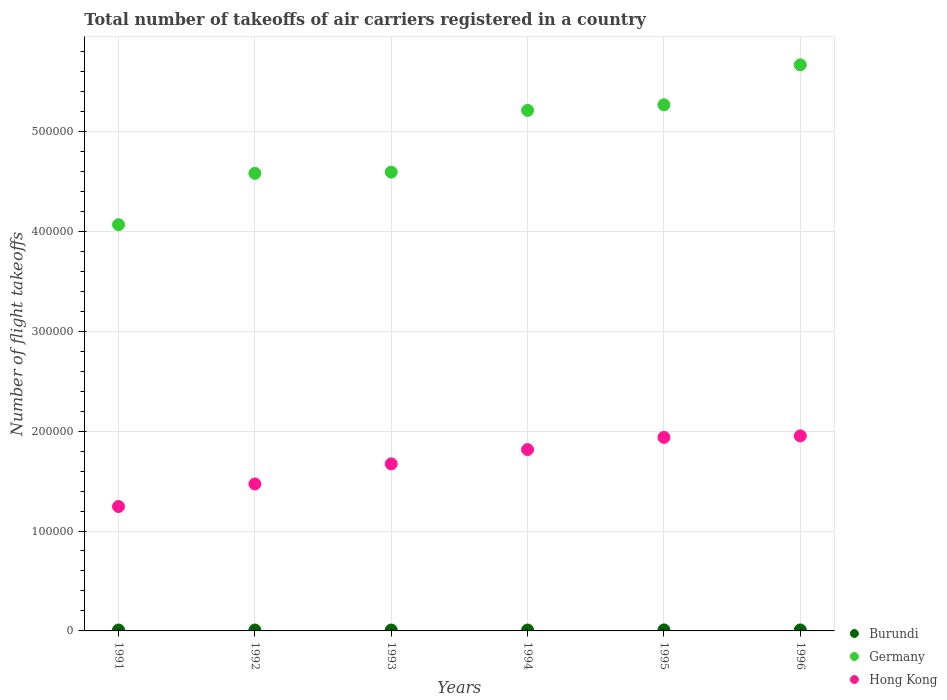How many different coloured dotlines are there?
Your answer should be very brief. 3. Across all years, what is the maximum total number of flight takeoffs in Hong Kong?
Provide a short and direct response. 1.95e+05. Across all years, what is the minimum total number of flight takeoffs in Germany?
Keep it short and to the point. 4.07e+05. In which year was the total number of flight takeoffs in Burundi minimum?
Provide a short and direct response. 1991. What is the total total number of flight takeoffs in Burundi in the graph?
Offer a very short reply. 5600. What is the difference between the total number of flight takeoffs in Burundi in 1993 and that in 1995?
Provide a succinct answer. -100. What is the difference between the total number of flight takeoffs in Burundi in 1993 and the total number of flight takeoffs in Germany in 1994?
Give a very brief answer. -5.20e+05. What is the average total number of flight takeoffs in Hong Kong per year?
Keep it short and to the point. 1.68e+05. In the year 1994, what is the difference between the total number of flight takeoffs in Germany and total number of flight takeoffs in Burundi?
Give a very brief answer. 5.20e+05. What is the ratio of the total number of flight takeoffs in Germany in 1991 to that in 1992?
Provide a short and direct response. 0.89. Is the difference between the total number of flight takeoffs in Germany in 1992 and 1993 greater than the difference between the total number of flight takeoffs in Burundi in 1992 and 1993?
Make the answer very short. No. What is the difference between the highest and the second highest total number of flight takeoffs in Hong Kong?
Offer a terse response. 1500. Is it the case that in every year, the sum of the total number of flight takeoffs in Burundi and total number of flight takeoffs in Germany  is greater than the total number of flight takeoffs in Hong Kong?
Ensure brevity in your answer.  Yes. Does the graph contain any zero values?
Provide a short and direct response. No. Does the graph contain grids?
Offer a terse response. Yes. How many legend labels are there?
Offer a very short reply. 3. How are the legend labels stacked?
Offer a terse response. Vertical. What is the title of the graph?
Your answer should be very brief. Total number of takeoffs of air carriers registered in a country. What is the label or title of the Y-axis?
Provide a short and direct response. Number of flight takeoffs. What is the Number of flight takeoffs of Burundi in 1991?
Provide a succinct answer. 900. What is the Number of flight takeoffs of Germany in 1991?
Give a very brief answer. 4.07e+05. What is the Number of flight takeoffs of Hong Kong in 1991?
Your answer should be compact. 1.24e+05. What is the Number of flight takeoffs of Burundi in 1992?
Provide a succinct answer. 900. What is the Number of flight takeoffs in Germany in 1992?
Ensure brevity in your answer.  4.58e+05. What is the Number of flight takeoffs in Hong Kong in 1992?
Offer a terse response. 1.47e+05. What is the Number of flight takeoffs in Burundi in 1993?
Ensure brevity in your answer.  900. What is the Number of flight takeoffs in Germany in 1993?
Provide a short and direct response. 4.59e+05. What is the Number of flight takeoffs in Hong Kong in 1993?
Provide a succinct answer. 1.67e+05. What is the Number of flight takeoffs in Burundi in 1994?
Offer a very short reply. 900. What is the Number of flight takeoffs in Germany in 1994?
Your response must be concise. 5.21e+05. What is the Number of flight takeoffs in Hong Kong in 1994?
Make the answer very short. 1.82e+05. What is the Number of flight takeoffs of Burundi in 1995?
Your answer should be very brief. 1000. What is the Number of flight takeoffs of Germany in 1995?
Keep it short and to the point. 5.27e+05. What is the Number of flight takeoffs in Hong Kong in 1995?
Provide a short and direct response. 1.94e+05. What is the Number of flight takeoffs of Germany in 1996?
Give a very brief answer. 5.67e+05. What is the Number of flight takeoffs of Hong Kong in 1996?
Keep it short and to the point. 1.95e+05. Across all years, what is the maximum Number of flight takeoffs of Germany?
Provide a short and direct response. 5.67e+05. Across all years, what is the maximum Number of flight takeoffs of Hong Kong?
Give a very brief answer. 1.95e+05. Across all years, what is the minimum Number of flight takeoffs of Burundi?
Your answer should be very brief. 900. Across all years, what is the minimum Number of flight takeoffs in Germany?
Keep it short and to the point. 4.07e+05. Across all years, what is the minimum Number of flight takeoffs in Hong Kong?
Keep it short and to the point. 1.24e+05. What is the total Number of flight takeoffs in Burundi in the graph?
Make the answer very short. 5600. What is the total Number of flight takeoffs in Germany in the graph?
Your response must be concise. 2.94e+06. What is the total Number of flight takeoffs of Hong Kong in the graph?
Provide a short and direct response. 1.01e+06. What is the difference between the Number of flight takeoffs in Germany in 1991 and that in 1992?
Provide a succinct answer. -5.14e+04. What is the difference between the Number of flight takeoffs in Hong Kong in 1991 and that in 1992?
Provide a succinct answer. -2.26e+04. What is the difference between the Number of flight takeoffs in Germany in 1991 and that in 1993?
Offer a terse response. -5.26e+04. What is the difference between the Number of flight takeoffs of Hong Kong in 1991 and that in 1993?
Your response must be concise. -4.27e+04. What is the difference between the Number of flight takeoffs of Germany in 1991 and that in 1994?
Keep it short and to the point. -1.14e+05. What is the difference between the Number of flight takeoffs of Hong Kong in 1991 and that in 1994?
Offer a terse response. -5.70e+04. What is the difference between the Number of flight takeoffs of Burundi in 1991 and that in 1995?
Make the answer very short. -100. What is the difference between the Number of flight takeoffs of Germany in 1991 and that in 1995?
Ensure brevity in your answer.  -1.20e+05. What is the difference between the Number of flight takeoffs of Hong Kong in 1991 and that in 1995?
Make the answer very short. -6.92e+04. What is the difference between the Number of flight takeoffs in Burundi in 1991 and that in 1996?
Your answer should be compact. -100. What is the difference between the Number of flight takeoffs in Hong Kong in 1991 and that in 1996?
Offer a very short reply. -7.07e+04. What is the difference between the Number of flight takeoffs in Germany in 1992 and that in 1993?
Keep it short and to the point. -1200. What is the difference between the Number of flight takeoffs of Hong Kong in 1992 and that in 1993?
Your answer should be very brief. -2.01e+04. What is the difference between the Number of flight takeoffs in Germany in 1992 and that in 1994?
Offer a terse response. -6.30e+04. What is the difference between the Number of flight takeoffs in Hong Kong in 1992 and that in 1994?
Make the answer very short. -3.44e+04. What is the difference between the Number of flight takeoffs of Burundi in 1992 and that in 1995?
Give a very brief answer. -100. What is the difference between the Number of flight takeoffs of Germany in 1992 and that in 1995?
Ensure brevity in your answer.  -6.86e+04. What is the difference between the Number of flight takeoffs in Hong Kong in 1992 and that in 1995?
Make the answer very short. -4.66e+04. What is the difference between the Number of flight takeoffs of Burundi in 1992 and that in 1996?
Make the answer very short. -100. What is the difference between the Number of flight takeoffs of Germany in 1992 and that in 1996?
Provide a succinct answer. -1.09e+05. What is the difference between the Number of flight takeoffs of Hong Kong in 1992 and that in 1996?
Your response must be concise. -4.81e+04. What is the difference between the Number of flight takeoffs of Burundi in 1993 and that in 1994?
Provide a short and direct response. 0. What is the difference between the Number of flight takeoffs in Germany in 1993 and that in 1994?
Provide a succinct answer. -6.18e+04. What is the difference between the Number of flight takeoffs of Hong Kong in 1993 and that in 1994?
Make the answer very short. -1.43e+04. What is the difference between the Number of flight takeoffs in Burundi in 1993 and that in 1995?
Provide a succinct answer. -100. What is the difference between the Number of flight takeoffs in Germany in 1993 and that in 1995?
Your response must be concise. -6.74e+04. What is the difference between the Number of flight takeoffs of Hong Kong in 1993 and that in 1995?
Your answer should be compact. -2.65e+04. What is the difference between the Number of flight takeoffs in Burundi in 1993 and that in 1996?
Make the answer very short. -100. What is the difference between the Number of flight takeoffs of Germany in 1993 and that in 1996?
Your response must be concise. -1.07e+05. What is the difference between the Number of flight takeoffs of Hong Kong in 1993 and that in 1996?
Offer a terse response. -2.80e+04. What is the difference between the Number of flight takeoffs of Burundi in 1994 and that in 1995?
Your answer should be very brief. -100. What is the difference between the Number of flight takeoffs in Germany in 1994 and that in 1995?
Ensure brevity in your answer.  -5600. What is the difference between the Number of flight takeoffs of Hong Kong in 1994 and that in 1995?
Give a very brief answer. -1.22e+04. What is the difference between the Number of flight takeoffs of Burundi in 1994 and that in 1996?
Make the answer very short. -100. What is the difference between the Number of flight takeoffs in Germany in 1994 and that in 1996?
Your answer should be compact. -4.56e+04. What is the difference between the Number of flight takeoffs in Hong Kong in 1994 and that in 1996?
Provide a short and direct response. -1.37e+04. What is the difference between the Number of flight takeoffs of Burundi in 1995 and that in 1996?
Give a very brief answer. 0. What is the difference between the Number of flight takeoffs in Germany in 1995 and that in 1996?
Ensure brevity in your answer.  -4.00e+04. What is the difference between the Number of flight takeoffs in Hong Kong in 1995 and that in 1996?
Offer a terse response. -1500. What is the difference between the Number of flight takeoffs of Burundi in 1991 and the Number of flight takeoffs of Germany in 1992?
Your answer should be compact. -4.57e+05. What is the difference between the Number of flight takeoffs of Burundi in 1991 and the Number of flight takeoffs of Hong Kong in 1992?
Offer a very short reply. -1.46e+05. What is the difference between the Number of flight takeoffs of Germany in 1991 and the Number of flight takeoffs of Hong Kong in 1992?
Ensure brevity in your answer.  2.60e+05. What is the difference between the Number of flight takeoffs in Burundi in 1991 and the Number of flight takeoffs in Germany in 1993?
Offer a terse response. -4.58e+05. What is the difference between the Number of flight takeoffs in Burundi in 1991 and the Number of flight takeoffs in Hong Kong in 1993?
Your response must be concise. -1.66e+05. What is the difference between the Number of flight takeoffs of Germany in 1991 and the Number of flight takeoffs of Hong Kong in 1993?
Ensure brevity in your answer.  2.39e+05. What is the difference between the Number of flight takeoffs of Burundi in 1991 and the Number of flight takeoffs of Germany in 1994?
Give a very brief answer. -5.20e+05. What is the difference between the Number of flight takeoffs of Burundi in 1991 and the Number of flight takeoffs of Hong Kong in 1994?
Offer a very short reply. -1.81e+05. What is the difference between the Number of flight takeoffs of Germany in 1991 and the Number of flight takeoffs of Hong Kong in 1994?
Offer a very short reply. 2.25e+05. What is the difference between the Number of flight takeoffs in Burundi in 1991 and the Number of flight takeoffs in Germany in 1995?
Offer a terse response. -5.26e+05. What is the difference between the Number of flight takeoffs of Burundi in 1991 and the Number of flight takeoffs of Hong Kong in 1995?
Ensure brevity in your answer.  -1.93e+05. What is the difference between the Number of flight takeoffs of Germany in 1991 and the Number of flight takeoffs of Hong Kong in 1995?
Give a very brief answer. 2.13e+05. What is the difference between the Number of flight takeoffs in Burundi in 1991 and the Number of flight takeoffs in Germany in 1996?
Your answer should be compact. -5.66e+05. What is the difference between the Number of flight takeoffs of Burundi in 1991 and the Number of flight takeoffs of Hong Kong in 1996?
Make the answer very short. -1.94e+05. What is the difference between the Number of flight takeoffs in Germany in 1991 and the Number of flight takeoffs in Hong Kong in 1996?
Your answer should be very brief. 2.11e+05. What is the difference between the Number of flight takeoffs in Burundi in 1992 and the Number of flight takeoffs in Germany in 1993?
Ensure brevity in your answer.  -4.58e+05. What is the difference between the Number of flight takeoffs in Burundi in 1992 and the Number of flight takeoffs in Hong Kong in 1993?
Give a very brief answer. -1.66e+05. What is the difference between the Number of flight takeoffs of Germany in 1992 and the Number of flight takeoffs of Hong Kong in 1993?
Make the answer very short. 2.91e+05. What is the difference between the Number of flight takeoffs in Burundi in 1992 and the Number of flight takeoffs in Germany in 1994?
Make the answer very short. -5.20e+05. What is the difference between the Number of flight takeoffs of Burundi in 1992 and the Number of flight takeoffs of Hong Kong in 1994?
Make the answer very short. -1.81e+05. What is the difference between the Number of flight takeoffs in Germany in 1992 and the Number of flight takeoffs in Hong Kong in 1994?
Provide a succinct answer. 2.76e+05. What is the difference between the Number of flight takeoffs of Burundi in 1992 and the Number of flight takeoffs of Germany in 1995?
Your answer should be very brief. -5.26e+05. What is the difference between the Number of flight takeoffs in Burundi in 1992 and the Number of flight takeoffs in Hong Kong in 1995?
Your answer should be compact. -1.93e+05. What is the difference between the Number of flight takeoffs of Germany in 1992 and the Number of flight takeoffs of Hong Kong in 1995?
Offer a terse response. 2.64e+05. What is the difference between the Number of flight takeoffs in Burundi in 1992 and the Number of flight takeoffs in Germany in 1996?
Offer a terse response. -5.66e+05. What is the difference between the Number of flight takeoffs of Burundi in 1992 and the Number of flight takeoffs of Hong Kong in 1996?
Ensure brevity in your answer.  -1.94e+05. What is the difference between the Number of flight takeoffs of Germany in 1992 and the Number of flight takeoffs of Hong Kong in 1996?
Ensure brevity in your answer.  2.63e+05. What is the difference between the Number of flight takeoffs of Burundi in 1993 and the Number of flight takeoffs of Germany in 1994?
Provide a short and direct response. -5.20e+05. What is the difference between the Number of flight takeoffs in Burundi in 1993 and the Number of flight takeoffs in Hong Kong in 1994?
Your answer should be very brief. -1.81e+05. What is the difference between the Number of flight takeoffs of Germany in 1993 and the Number of flight takeoffs of Hong Kong in 1994?
Offer a terse response. 2.78e+05. What is the difference between the Number of flight takeoffs in Burundi in 1993 and the Number of flight takeoffs in Germany in 1995?
Provide a short and direct response. -5.26e+05. What is the difference between the Number of flight takeoffs of Burundi in 1993 and the Number of flight takeoffs of Hong Kong in 1995?
Offer a very short reply. -1.93e+05. What is the difference between the Number of flight takeoffs in Germany in 1993 and the Number of flight takeoffs in Hong Kong in 1995?
Your response must be concise. 2.66e+05. What is the difference between the Number of flight takeoffs of Burundi in 1993 and the Number of flight takeoffs of Germany in 1996?
Keep it short and to the point. -5.66e+05. What is the difference between the Number of flight takeoffs of Burundi in 1993 and the Number of flight takeoffs of Hong Kong in 1996?
Offer a very short reply. -1.94e+05. What is the difference between the Number of flight takeoffs in Germany in 1993 and the Number of flight takeoffs in Hong Kong in 1996?
Provide a short and direct response. 2.64e+05. What is the difference between the Number of flight takeoffs of Burundi in 1994 and the Number of flight takeoffs of Germany in 1995?
Ensure brevity in your answer.  -5.26e+05. What is the difference between the Number of flight takeoffs of Burundi in 1994 and the Number of flight takeoffs of Hong Kong in 1995?
Give a very brief answer. -1.93e+05. What is the difference between the Number of flight takeoffs in Germany in 1994 and the Number of flight takeoffs in Hong Kong in 1995?
Keep it short and to the point. 3.27e+05. What is the difference between the Number of flight takeoffs of Burundi in 1994 and the Number of flight takeoffs of Germany in 1996?
Make the answer very short. -5.66e+05. What is the difference between the Number of flight takeoffs of Burundi in 1994 and the Number of flight takeoffs of Hong Kong in 1996?
Give a very brief answer. -1.94e+05. What is the difference between the Number of flight takeoffs in Germany in 1994 and the Number of flight takeoffs in Hong Kong in 1996?
Keep it short and to the point. 3.26e+05. What is the difference between the Number of flight takeoffs of Burundi in 1995 and the Number of flight takeoffs of Germany in 1996?
Your response must be concise. -5.66e+05. What is the difference between the Number of flight takeoffs of Burundi in 1995 and the Number of flight takeoffs of Hong Kong in 1996?
Provide a succinct answer. -1.94e+05. What is the difference between the Number of flight takeoffs of Germany in 1995 and the Number of flight takeoffs of Hong Kong in 1996?
Offer a terse response. 3.31e+05. What is the average Number of flight takeoffs in Burundi per year?
Provide a short and direct response. 933.33. What is the average Number of flight takeoffs in Germany per year?
Give a very brief answer. 4.90e+05. What is the average Number of flight takeoffs of Hong Kong per year?
Give a very brief answer. 1.68e+05. In the year 1991, what is the difference between the Number of flight takeoffs of Burundi and Number of flight takeoffs of Germany?
Provide a short and direct response. -4.06e+05. In the year 1991, what is the difference between the Number of flight takeoffs in Burundi and Number of flight takeoffs in Hong Kong?
Your response must be concise. -1.24e+05. In the year 1991, what is the difference between the Number of flight takeoffs in Germany and Number of flight takeoffs in Hong Kong?
Give a very brief answer. 2.82e+05. In the year 1992, what is the difference between the Number of flight takeoffs in Burundi and Number of flight takeoffs in Germany?
Offer a terse response. -4.57e+05. In the year 1992, what is the difference between the Number of flight takeoffs of Burundi and Number of flight takeoffs of Hong Kong?
Your answer should be compact. -1.46e+05. In the year 1992, what is the difference between the Number of flight takeoffs of Germany and Number of flight takeoffs of Hong Kong?
Your answer should be compact. 3.11e+05. In the year 1993, what is the difference between the Number of flight takeoffs in Burundi and Number of flight takeoffs in Germany?
Your response must be concise. -4.58e+05. In the year 1993, what is the difference between the Number of flight takeoffs of Burundi and Number of flight takeoffs of Hong Kong?
Ensure brevity in your answer.  -1.66e+05. In the year 1993, what is the difference between the Number of flight takeoffs in Germany and Number of flight takeoffs in Hong Kong?
Your response must be concise. 2.92e+05. In the year 1994, what is the difference between the Number of flight takeoffs in Burundi and Number of flight takeoffs in Germany?
Offer a terse response. -5.20e+05. In the year 1994, what is the difference between the Number of flight takeoffs of Burundi and Number of flight takeoffs of Hong Kong?
Your answer should be very brief. -1.81e+05. In the year 1994, what is the difference between the Number of flight takeoffs in Germany and Number of flight takeoffs in Hong Kong?
Ensure brevity in your answer.  3.40e+05. In the year 1995, what is the difference between the Number of flight takeoffs in Burundi and Number of flight takeoffs in Germany?
Your answer should be very brief. -5.26e+05. In the year 1995, what is the difference between the Number of flight takeoffs in Burundi and Number of flight takeoffs in Hong Kong?
Offer a terse response. -1.93e+05. In the year 1995, what is the difference between the Number of flight takeoffs in Germany and Number of flight takeoffs in Hong Kong?
Give a very brief answer. 3.33e+05. In the year 1996, what is the difference between the Number of flight takeoffs of Burundi and Number of flight takeoffs of Germany?
Provide a short and direct response. -5.66e+05. In the year 1996, what is the difference between the Number of flight takeoffs of Burundi and Number of flight takeoffs of Hong Kong?
Offer a terse response. -1.94e+05. In the year 1996, what is the difference between the Number of flight takeoffs of Germany and Number of flight takeoffs of Hong Kong?
Make the answer very short. 3.71e+05. What is the ratio of the Number of flight takeoffs in Germany in 1991 to that in 1992?
Provide a short and direct response. 0.89. What is the ratio of the Number of flight takeoffs of Hong Kong in 1991 to that in 1992?
Your response must be concise. 0.85. What is the ratio of the Number of flight takeoffs of Burundi in 1991 to that in 1993?
Keep it short and to the point. 1. What is the ratio of the Number of flight takeoffs of Germany in 1991 to that in 1993?
Provide a succinct answer. 0.89. What is the ratio of the Number of flight takeoffs of Hong Kong in 1991 to that in 1993?
Offer a very short reply. 0.74. What is the ratio of the Number of flight takeoffs of Burundi in 1991 to that in 1994?
Your answer should be very brief. 1. What is the ratio of the Number of flight takeoffs in Germany in 1991 to that in 1994?
Your response must be concise. 0.78. What is the ratio of the Number of flight takeoffs of Hong Kong in 1991 to that in 1994?
Offer a very short reply. 0.69. What is the ratio of the Number of flight takeoffs in Germany in 1991 to that in 1995?
Offer a very short reply. 0.77. What is the ratio of the Number of flight takeoffs of Hong Kong in 1991 to that in 1995?
Your answer should be compact. 0.64. What is the ratio of the Number of flight takeoffs of Burundi in 1991 to that in 1996?
Your response must be concise. 0.9. What is the ratio of the Number of flight takeoffs in Germany in 1991 to that in 1996?
Offer a very short reply. 0.72. What is the ratio of the Number of flight takeoffs in Hong Kong in 1991 to that in 1996?
Provide a succinct answer. 0.64. What is the ratio of the Number of flight takeoffs of Hong Kong in 1992 to that in 1993?
Keep it short and to the point. 0.88. What is the ratio of the Number of flight takeoffs of Burundi in 1992 to that in 1994?
Your response must be concise. 1. What is the ratio of the Number of flight takeoffs in Germany in 1992 to that in 1994?
Offer a very short reply. 0.88. What is the ratio of the Number of flight takeoffs of Hong Kong in 1992 to that in 1994?
Give a very brief answer. 0.81. What is the ratio of the Number of flight takeoffs in Burundi in 1992 to that in 1995?
Provide a succinct answer. 0.9. What is the ratio of the Number of flight takeoffs in Germany in 1992 to that in 1995?
Your answer should be compact. 0.87. What is the ratio of the Number of flight takeoffs in Hong Kong in 1992 to that in 1995?
Make the answer very short. 0.76. What is the ratio of the Number of flight takeoffs of Burundi in 1992 to that in 1996?
Your answer should be compact. 0.9. What is the ratio of the Number of flight takeoffs in Germany in 1992 to that in 1996?
Make the answer very short. 0.81. What is the ratio of the Number of flight takeoffs in Hong Kong in 1992 to that in 1996?
Your answer should be very brief. 0.75. What is the ratio of the Number of flight takeoffs of Burundi in 1993 to that in 1994?
Offer a very short reply. 1. What is the ratio of the Number of flight takeoffs of Germany in 1993 to that in 1994?
Provide a short and direct response. 0.88. What is the ratio of the Number of flight takeoffs of Hong Kong in 1993 to that in 1994?
Your answer should be compact. 0.92. What is the ratio of the Number of flight takeoffs of Germany in 1993 to that in 1995?
Offer a terse response. 0.87. What is the ratio of the Number of flight takeoffs in Hong Kong in 1993 to that in 1995?
Your answer should be compact. 0.86. What is the ratio of the Number of flight takeoffs of Germany in 1993 to that in 1996?
Your answer should be compact. 0.81. What is the ratio of the Number of flight takeoffs of Hong Kong in 1993 to that in 1996?
Provide a short and direct response. 0.86. What is the ratio of the Number of flight takeoffs in Burundi in 1994 to that in 1995?
Offer a very short reply. 0.9. What is the ratio of the Number of flight takeoffs of Germany in 1994 to that in 1995?
Your answer should be compact. 0.99. What is the ratio of the Number of flight takeoffs in Hong Kong in 1994 to that in 1995?
Keep it short and to the point. 0.94. What is the ratio of the Number of flight takeoffs of Burundi in 1994 to that in 1996?
Ensure brevity in your answer.  0.9. What is the ratio of the Number of flight takeoffs in Germany in 1994 to that in 1996?
Provide a short and direct response. 0.92. What is the ratio of the Number of flight takeoffs in Hong Kong in 1994 to that in 1996?
Provide a short and direct response. 0.93. What is the ratio of the Number of flight takeoffs of Burundi in 1995 to that in 1996?
Provide a short and direct response. 1. What is the ratio of the Number of flight takeoffs of Germany in 1995 to that in 1996?
Your response must be concise. 0.93. What is the ratio of the Number of flight takeoffs in Hong Kong in 1995 to that in 1996?
Keep it short and to the point. 0.99. What is the difference between the highest and the second highest Number of flight takeoffs of Hong Kong?
Ensure brevity in your answer.  1500. What is the difference between the highest and the lowest Number of flight takeoffs in Burundi?
Your response must be concise. 100. What is the difference between the highest and the lowest Number of flight takeoffs in Hong Kong?
Provide a succinct answer. 7.07e+04. 